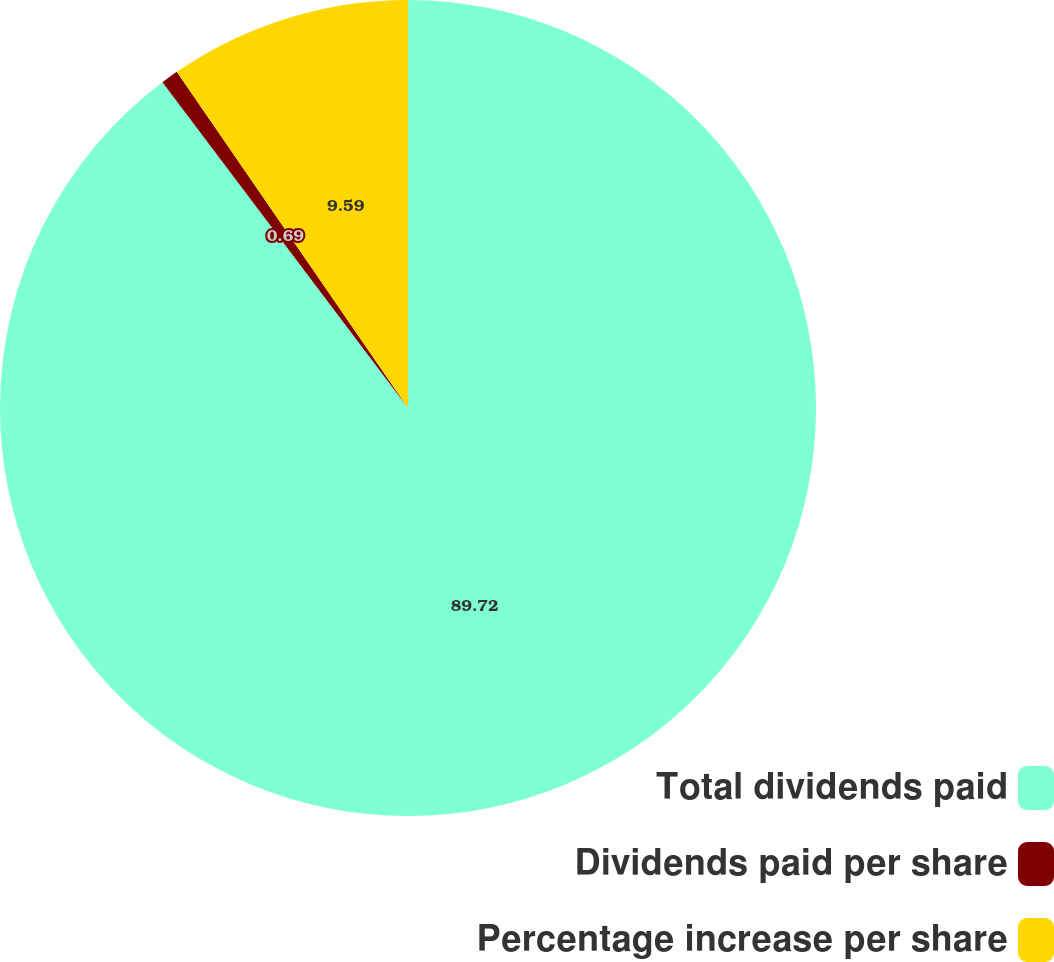<chart> <loc_0><loc_0><loc_500><loc_500><pie_chart><fcel>Total dividends paid<fcel>Dividends paid per share<fcel>Percentage increase per share<nl><fcel>89.72%<fcel>0.69%<fcel>9.59%<nl></chart> 